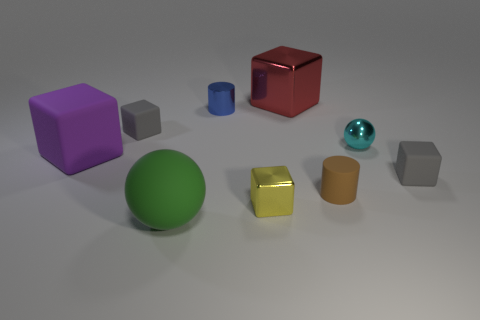Does the large green thing have the same shape as the gray object right of the small cyan thing? The large green object is a sphere, while the gray object to the right of the small cyan cylinder is a cube. Therefore, they do not have the same shape; one is round and the other has flat faces and edges. 